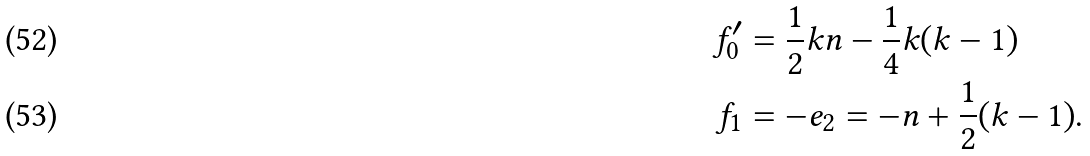Convert formula to latex. <formula><loc_0><loc_0><loc_500><loc_500>f ^ { \prime } _ { 0 } & = \frac { 1 } { 2 } k n - \frac { 1 } { 4 } k ( k - 1 ) \\ f _ { 1 } & = - e _ { 2 } = - n + \frac { 1 } { 2 } ( k - 1 ) .</formula> 